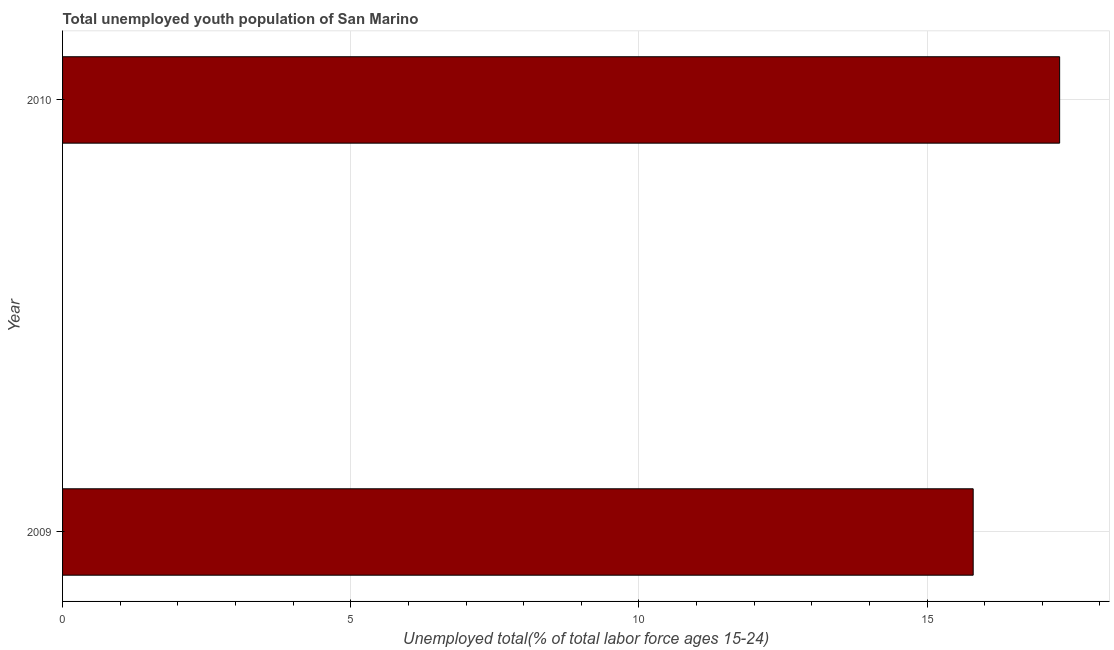What is the title of the graph?
Provide a short and direct response. Total unemployed youth population of San Marino. What is the label or title of the X-axis?
Offer a terse response. Unemployed total(% of total labor force ages 15-24). What is the unemployed youth in 2010?
Make the answer very short. 17.3. Across all years, what is the maximum unemployed youth?
Offer a terse response. 17.3. Across all years, what is the minimum unemployed youth?
Provide a short and direct response. 15.8. In which year was the unemployed youth maximum?
Provide a short and direct response. 2010. In which year was the unemployed youth minimum?
Offer a terse response. 2009. What is the sum of the unemployed youth?
Keep it short and to the point. 33.1. What is the average unemployed youth per year?
Provide a short and direct response. 16.55. What is the median unemployed youth?
Ensure brevity in your answer.  16.55. In how many years, is the unemployed youth greater than 1 %?
Provide a short and direct response. 2. Do a majority of the years between 2009 and 2010 (inclusive) have unemployed youth greater than 15 %?
Keep it short and to the point. Yes. What is the ratio of the unemployed youth in 2009 to that in 2010?
Keep it short and to the point. 0.91. Is the unemployed youth in 2009 less than that in 2010?
Keep it short and to the point. Yes. How many bars are there?
Offer a very short reply. 2. How many years are there in the graph?
Your answer should be compact. 2. What is the difference between two consecutive major ticks on the X-axis?
Provide a succinct answer. 5. Are the values on the major ticks of X-axis written in scientific E-notation?
Your answer should be compact. No. What is the Unemployed total(% of total labor force ages 15-24) in 2009?
Offer a very short reply. 15.8. What is the Unemployed total(% of total labor force ages 15-24) in 2010?
Make the answer very short. 17.3. What is the difference between the Unemployed total(% of total labor force ages 15-24) in 2009 and 2010?
Your answer should be very brief. -1.5. 